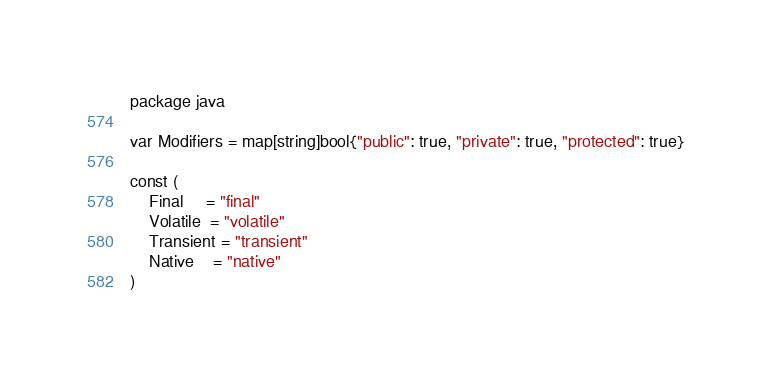Convert code to text. <code><loc_0><loc_0><loc_500><loc_500><_Go_>package java

var Modifiers = map[string]bool{"public": true, "private": true, "protected": true}

const (
	Final     = "final"
	Volatile  = "volatile"
	Transient = "transient"
	Native    = "native"
)
</code> 